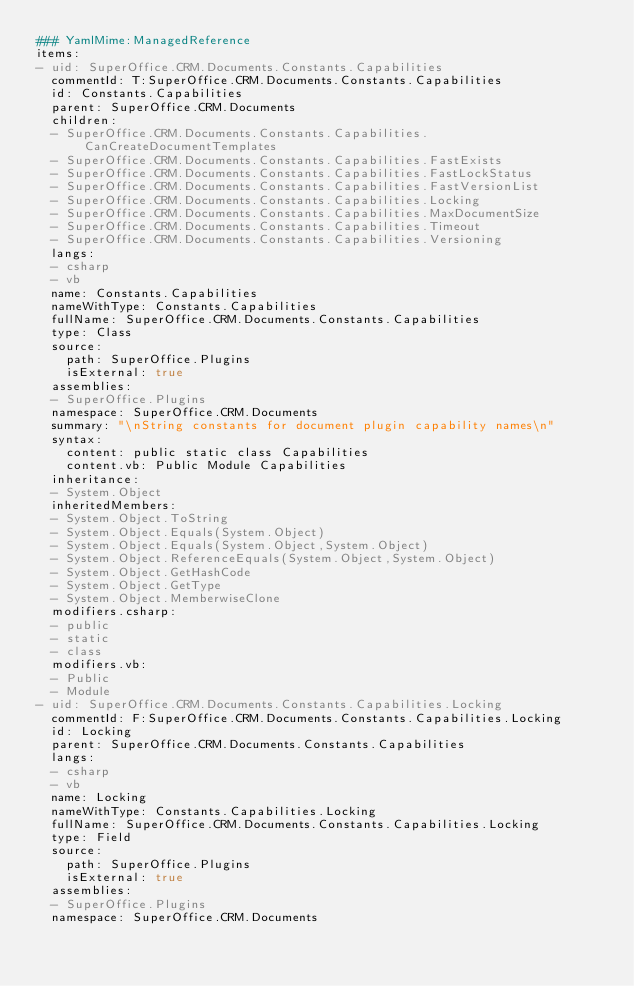Convert code to text. <code><loc_0><loc_0><loc_500><loc_500><_YAML_>### YamlMime:ManagedReference
items:
- uid: SuperOffice.CRM.Documents.Constants.Capabilities
  commentId: T:SuperOffice.CRM.Documents.Constants.Capabilities
  id: Constants.Capabilities
  parent: SuperOffice.CRM.Documents
  children:
  - SuperOffice.CRM.Documents.Constants.Capabilities.CanCreateDocumentTemplates
  - SuperOffice.CRM.Documents.Constants.Capabilities.FastExists
  - SuperOffice.CRM.Documents.Constants.Capabilities.FastLockStatus
  - SuperOffice.CRM.Documents.Constants.Capabilities.FastVersionList
  - SuperOffice.CRM.Documents.Constants.Capabilities.Locking
  - SuperOffice.CRM.Documents.Constants.Capabilities.MaxDocumentSize
  - SuperOffice.CRM.Documents.Constants.Capabilities.Timeout
  - SuperOffice.CRM.Documents.Constants.Capabilities.Versioning
  langs:
  - csharp
  - vb
  name: Constants.Capabilities
  nameWithType: Constants.Capabilities
  fullName: SuperOffice.CRM.Documents.Constants.Capabilities
  type: Class
  source:
    path: SuperOffice.Plugins
    isExternal: true
  assemblies:
  - SuperOffice.Plugins
  namespace: SuperOffice.CRM.Documents
  summary: "\nString constants for document plugin capability names\n"
  syntax:
    content: public static class Capabilities
    content.vb: Public Module Capabilities
  inheritance:
  - System.Object
  inheritedMembers:
  - System.Object.ToString
  - System.Object.Equals(System.Object)
  - System.Object.Equals(System.Object,System.Object)
  - System.Object.ReferenceEquals(System.Object,System.Object)
  - System.Object.GetHashCode
  - System.Object.GetType
  - System.Object.MemberwiseClone
  modifiers.csharp:
  - public
  - static
  - class
  modifiers.vb:
  - Public
  - Module
- uid: SuperOffice.CRM.Documents.Constants.Capabilities.Locking
  commentId: F:SuperOffice.CRM.Documents.Constants.Capabilities.Locking
  id: Locking
  parent: SuperOffice.CRM.Documents.Constants.Capabilities
  langs:
  - csharp
  - vb
  name: Locking
  nameWithType: Constants.Capabilities.Locking
  fullName: SuperOffice.CRM.Documents.Constants.Capabilities.Locking
  type: Field
  source:
    path: SuperOffice.Plugins
    isExternal: true
  assemblies:
  - SuperOffice.Plugins
  namespace: SuperOffice.CRM.Documents</code> 